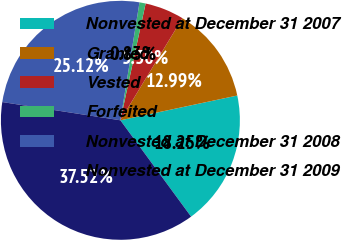Convert chart to OTSL. <chart><loc_0><loc_0><loc_500><loc_500><pie_chart><fcel>Nonvested at December 31 2007<fcel>Granted<fcel>Vested<fcel>Forfeited<fcel>Nonvested at December 31 2008<fcel>Nonvested at December 31 2009<nl><fcel>18.25%<fcel>12.99%<fcel>5.3%<fcel>0.83%<fcel>25.12%<fcel>37.52%<nl></chart> 